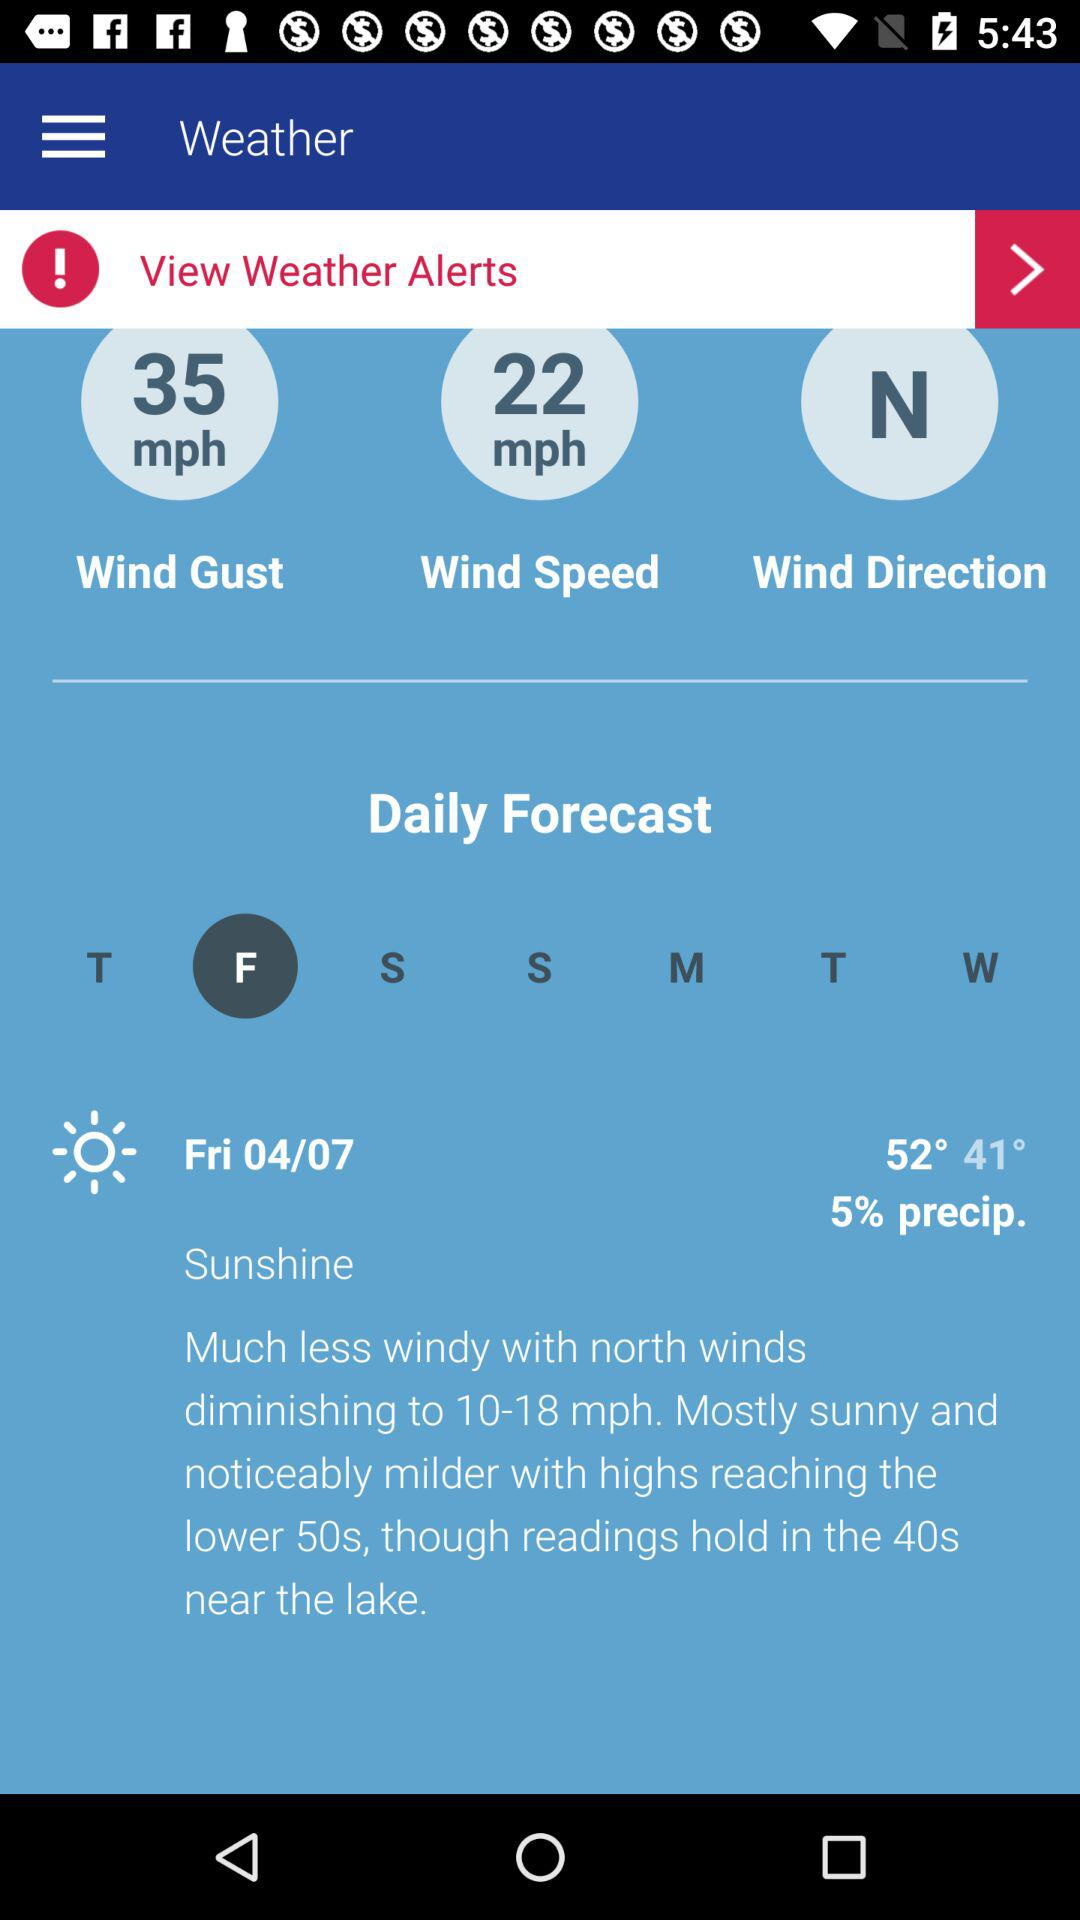What is the measured value of the wind gust? The measured value of the wind gust is 35 mph. 